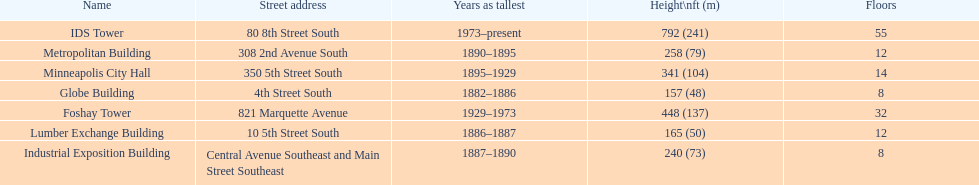Could you help me parse every detail presented in this table? {'header': ['Name', 'Street address', 'Years as tallest', 'Height\\nft (m)', 'Floors'], 'rows': [['IDS Tower', '80 8th Street South', '1973–present', '792 (241)', '55'], ['Metropolitan Building', '308 2nd Avenue South', '1890–1895', '258 (79)', '12'], ['Minneapolis City Hall', '350 5th Street South', '1895–1929', '341 (104)', '14'], ['Globe Building', '4th Street South', '1882–1886', '157 (48)', '8'], ['Foshay Tower', '821 Marquette Avenue', '1929–1973', '448 (137)', '32'], ['Lumber Exchange Building', '10 5th Street South', '1886–1887', '165 (50)', '12'], ['Industrial Exposition Building', 'Central Avenue Southeast and Main Street Southeast', '1887–1890', '240 (73)', '8']]} Which building has the same number of floors as the lumber exchange building? Metropolitan Building. 